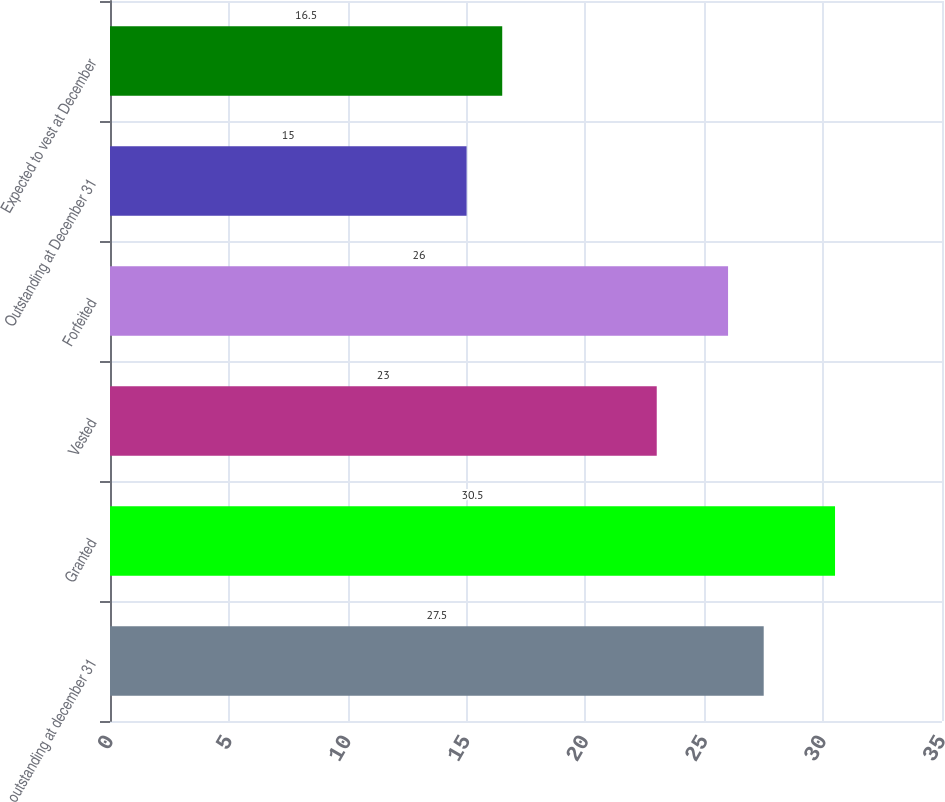Convert chart to OTSL. <chart><loc_0><loc_0><loc_500><loc_500><bar_chart><fcel>outstanding at december 31<fcel>Granted<fcel>Vested<fcel>Forfeited<fcel>Outstanding at December 31<fcel>Expected to vest at December<nl><fcel>27.5<fcel>30.5<fcel>23<fcel>26<fcel>15<fcel>16.5<nl></chart> 